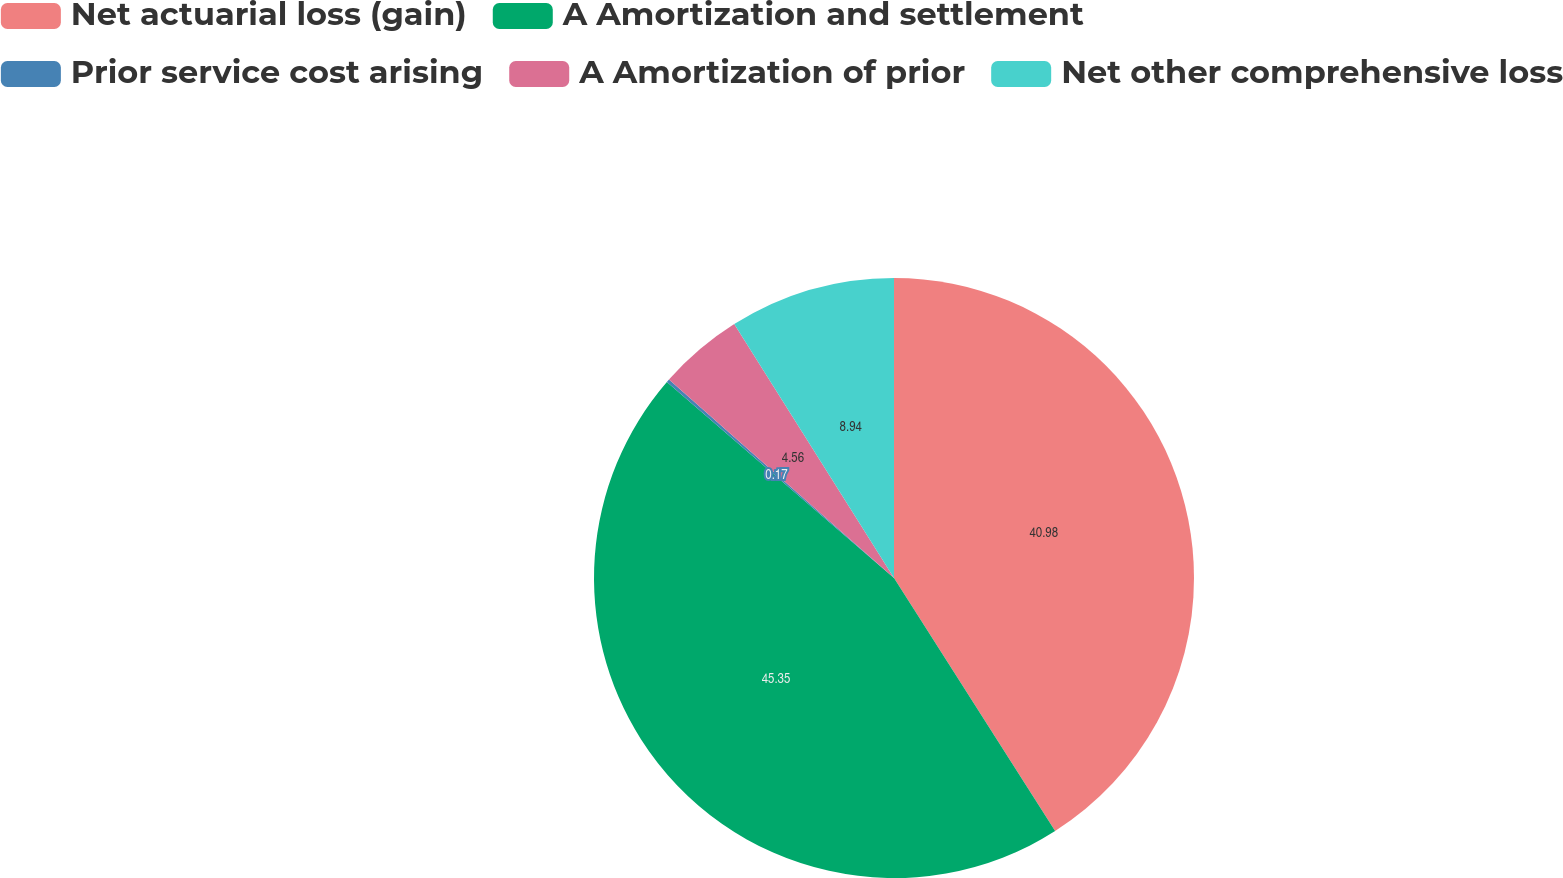<chart> <loc_0><loc_0><loc_500><loc_500><pie_chart><fcel>Net actuarial loss (gain)<fcel>A Amortization and settlement<fcel>Prior service cost arising<fcel>A Amortization of prior<fcel>Net other comprehensive loss<nl><fcel>40.98%<fcel>45.36%<fcel>0.17%<fcel>4.56%<fcel>8.94%<nl></chart> 